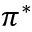Convert formula to latex. <formula><loc_0><loc_0><loc_500><loc_500>\pi ^ { * }</formula> 